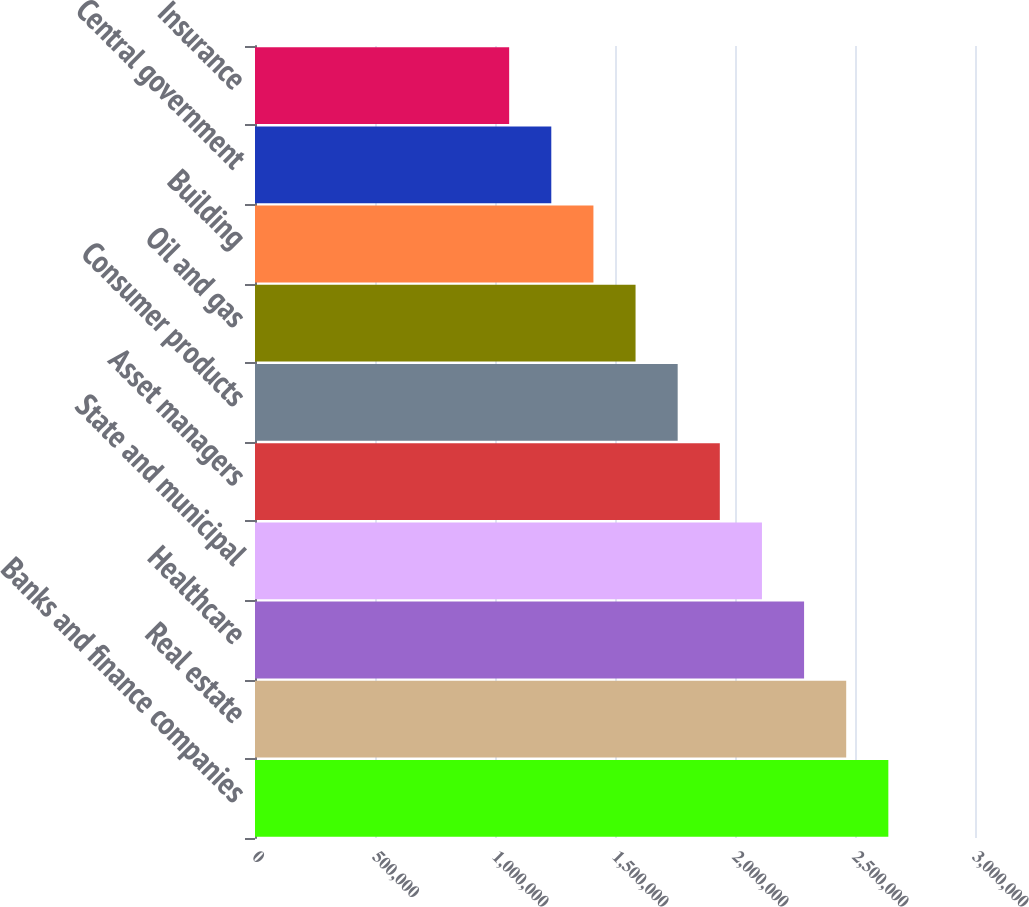Convert chart. <chart><loc_0><loc_0><loc_500><loc_500><bar_chart><fcel>Banks and finance companies<fcel>Real estate<fcel>Healthcare<fcel>State and municipal<fcel>Asset managers<fcel>Consumer products<fcel>Oil and gas<fcel>Building<fcel>Central government<fcel>Insurance<nl><fcel>2.6389e+06<fcel>2.46336e+06<fcel>2.28781e+06<fcel>2.11227e+06<fcel>1.93672e+06<fcel>1.76118e+06<fcel>1.58564e+06<fcel>1.41009e+06<fcel>1.23455e+06<fcel>1.059e+06<nl></chart> 